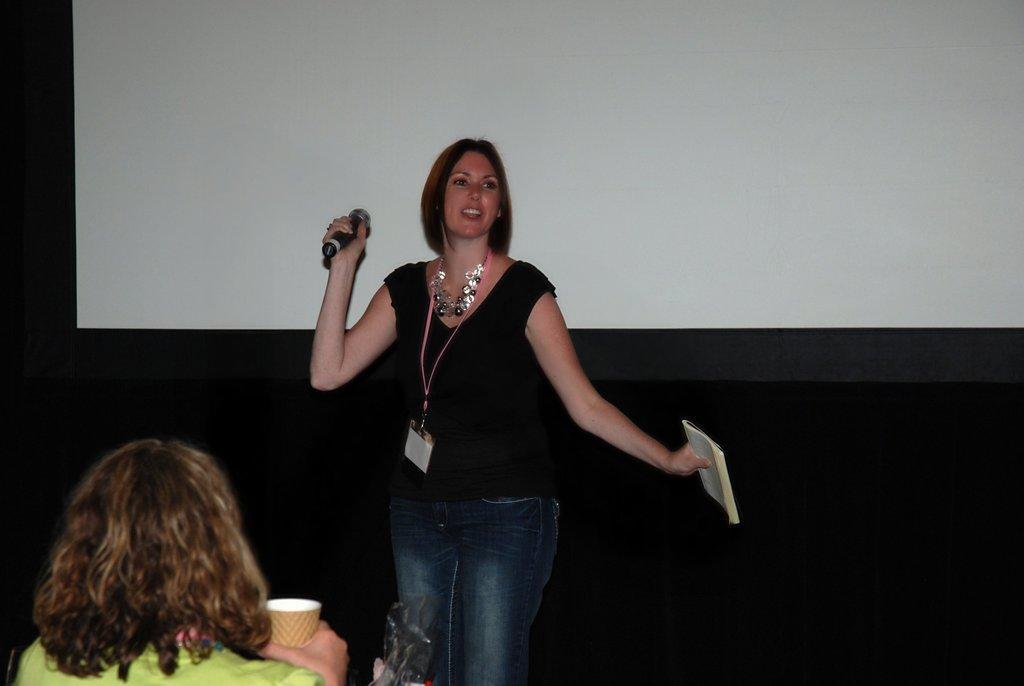In one or two sentences, can you explain what this image depicts? A lady with black top and a jeans is standing. She is holding a mic in one hand and book in another hand. In front of her there is a lady with green dress is sitting and holding a cup in her hand. In the background there is a screen. 